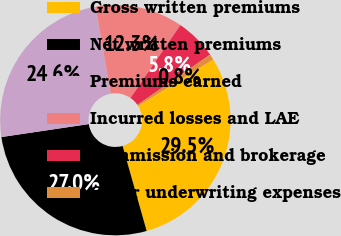Convert chart to OTSL. <chart><loc_0><loc_0><loc_500><loc_500><pie_chart><fcel>Gross written premiums<fcel>Net written premiums<fcel>Premiums earned<fcel>Incurred losses and LAE<fcel>Commission and brokerage<fcel>Other underwriting expenses<nl><fcel>29.47%<fcel>27.04%<fcel>24.61%<fcel>12.3%<fcel>5.82%<fcel>0.77%<nl></chart> 